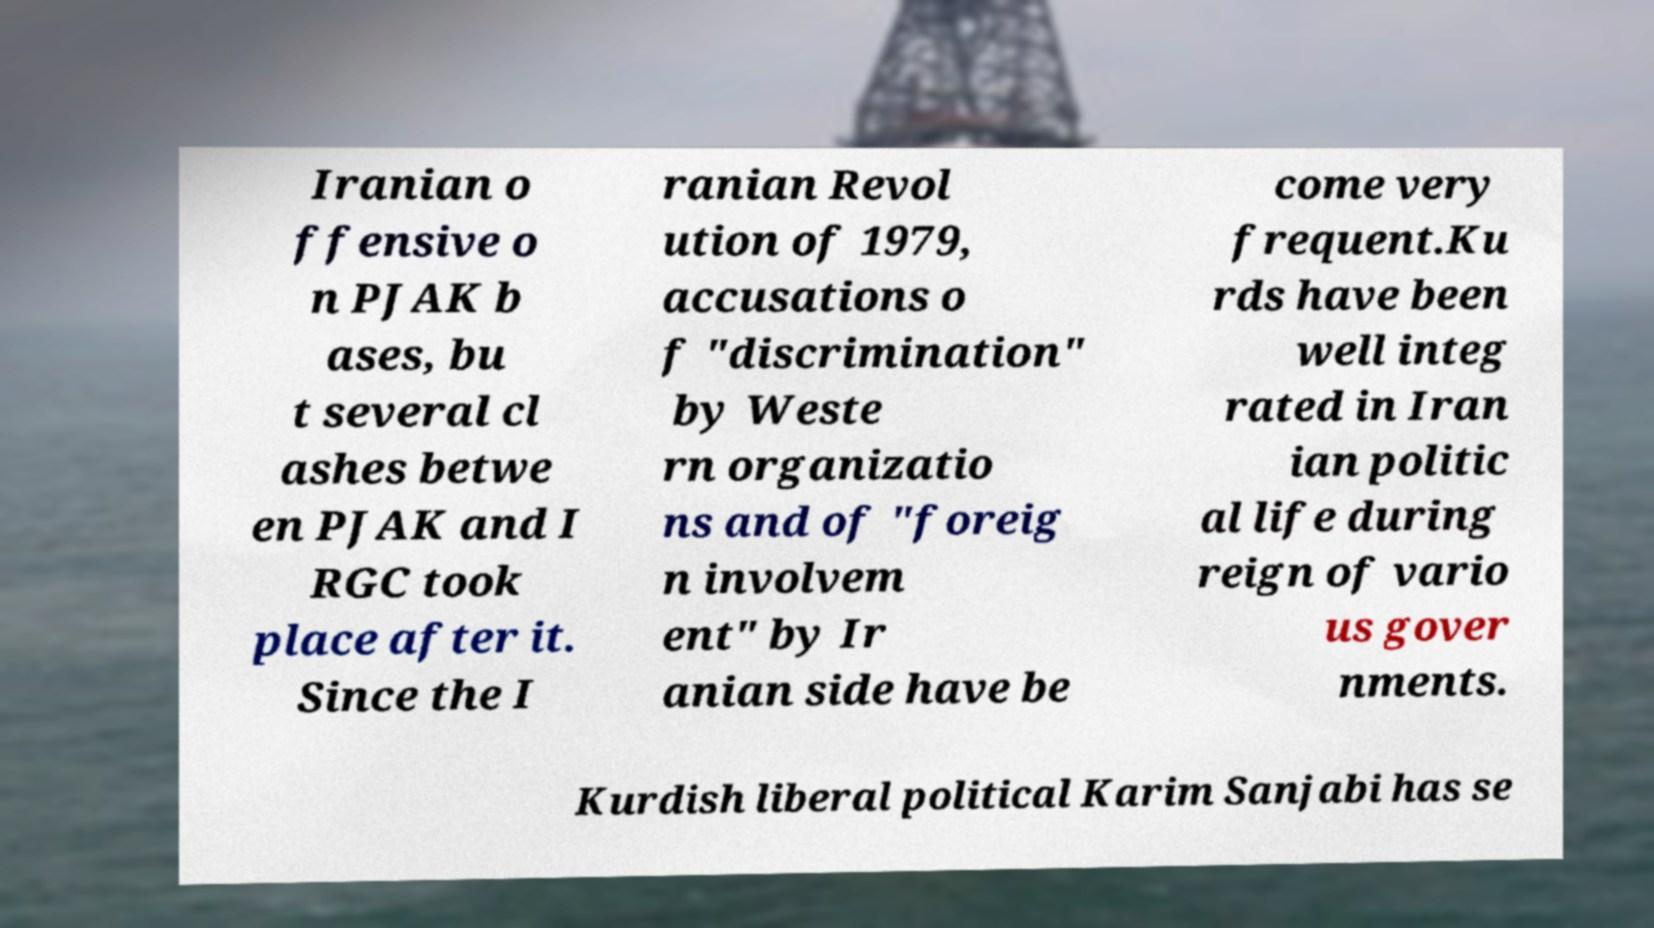I need the written content from this picture converted into text. Can you do that? Iranian o ffensive o n PJAK b ases, bu t several cl ashes betwe en PJAK and I RGC took place after it. Since the I ranian Revol ution of 1979, accusations o f "discrimination" by Weste rn organizatio ns and of "foreig n involvem ent" by Ir anian side have be come very frequent.Ku rds have been well integ rated in Iran ian politic al life during reign of vario us gover nments. Kurdish liberal political Karim Sanjabi has se 